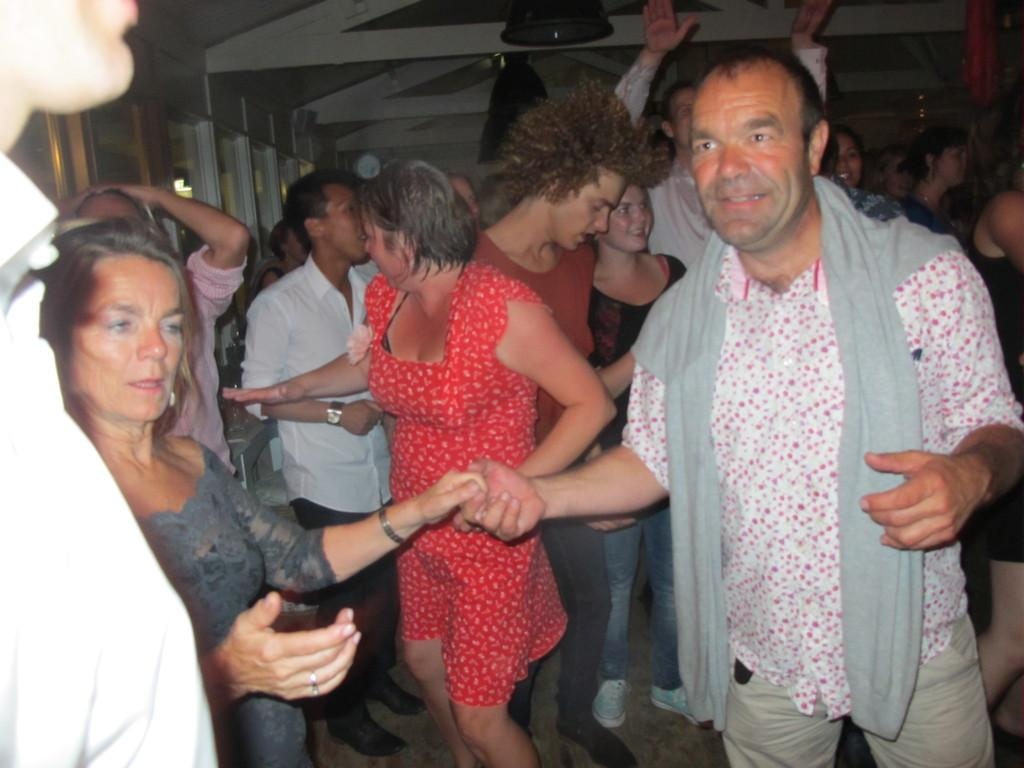What is happening in the image? There are persons standing in the image. What can be seen in the background of the image? There are lights on the ceiling, lights on the wall, and lights on other objects in the background of the image. What is the good-bye message written on the wall in the image? There is no good-bye message written on the wall in the image; the focus is on the lights in the background. 